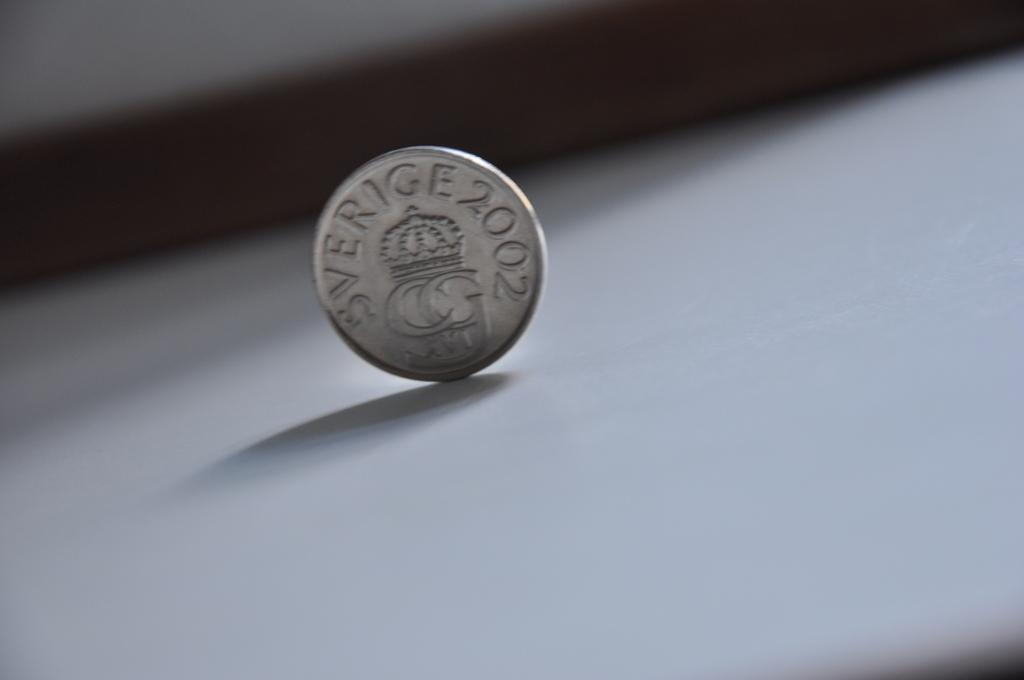Provide a one-sentence caption for the provided image. A coin, balanced on its edge that says Sverige 2002. 